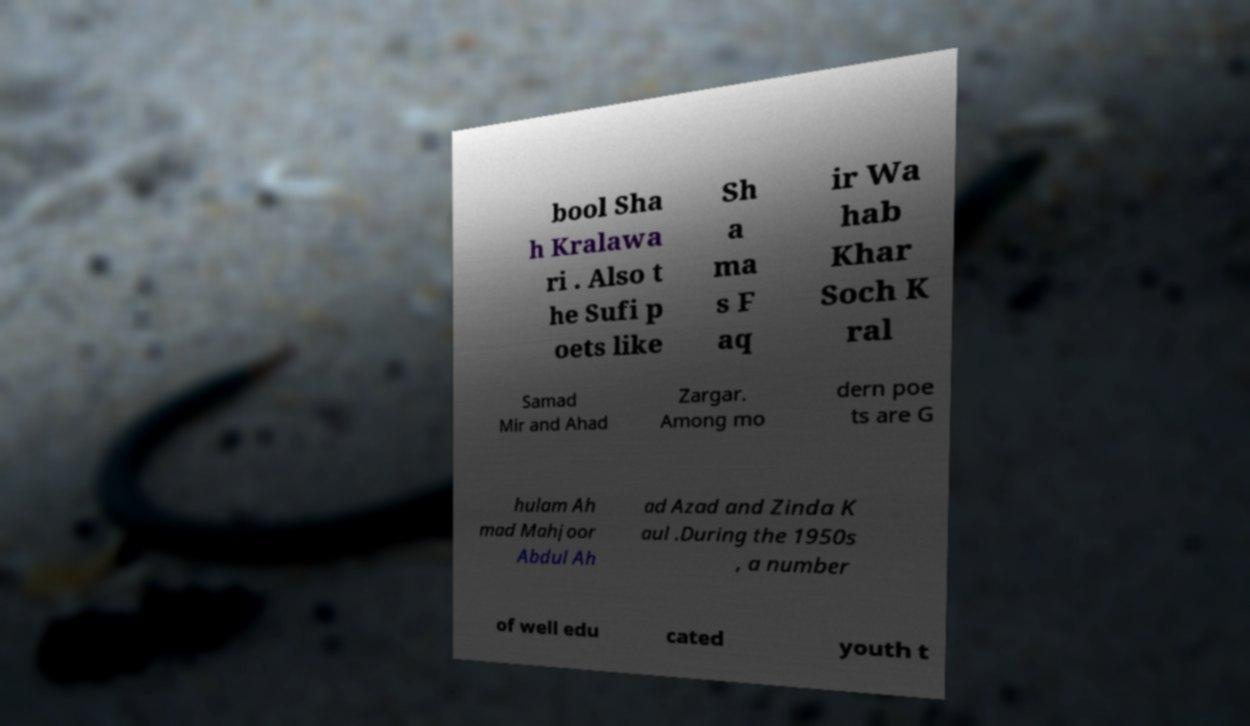Please read and relay the text visible in this image. What does it say? bool Sha h Kralawa ri . Also t he Sufi p oets like Sh a ma s F aq ir Wa hab Khar Soch K ral Samad Mir and Ahad Zargar. Among mo dern poe ts are G hulam Ah mad Mahjoor Abdul Ah ad Azad and Zinda K aul .During the 1950s , a number of well edu cated youth t 